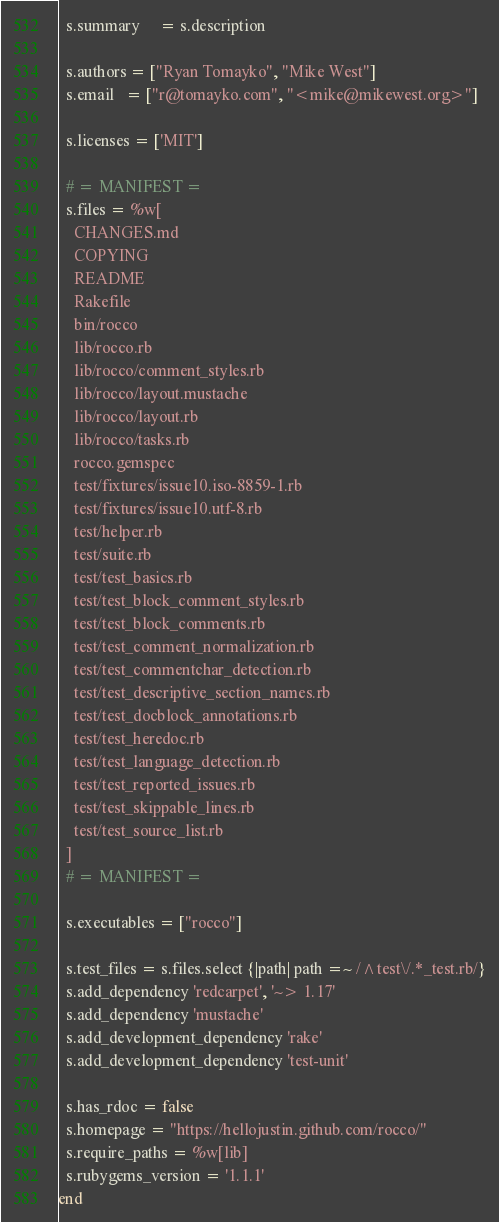<code> <loc_0><loc_0><loc_500><loc_500><_Ruby_>  s.summary     = s.description

  s.authors = ["Ryan Tomayko", "Mike West"]
  s.email   = ["r@tomayko.com", "<mike@mikewest.org>"]

  s.licenses = ['MIT']

  # = MANIFEST =
  s.files = %w[
    CHANGES.md
    COPYING
    README
    Rakefile
    bin/rocco
    lib/rocco.rb
    lib/rocco/comment_styles.rb
    lib/rocco/layout.mustache
    lib/rocco/layout.rb
    lib/rocco/tasks.rb
    rocco.gemspec
    test/fixtures/issue10.iso-8859-1.rb
    test/fixtures/issue10.utf-8.rb
    test/helper.rb
    test/suite.rb
    test/test_basics.rb
    test/test_block_comment_styles.rb
    test/test_block_comments.rb
    test/test_comment_normalization.rb
    test/test_commentchar_detection.rb
    test/test_descriptive_section_names.rb
    test/test_docblock_annotations.rb
    test/test_heredoc.rb
    test/test_language_detection.rb
    test/test_reported_issues.rb
    test/test_skippable_lines.rb
    test/test_source_list.rb
  ]
  # = MANIFEST =

  s.executables = ["rocco"]

  s.test_files = s.files.select {|path| path =~ /^test\/.*_test.rb/}
  s.add_dependency 'redcarpet', '~> 1.17'
  s.add_dependency 'mustache'
  s.add_development_dependency 'rake'
  s.add_development_dependency 'test-unit'

  s.has_rdoc = false
  s.homepage = "https://hellojustin.github.com/rocco/"
  s.require_paths = %w[lib]
  s.rubygems_version = '1.1.1'
end
</code> 